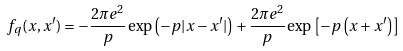Convert formula to latex. <formula><loc_0><loc_0><loc_500><loc_500>f _ { q } ( x , x ^ { \prime } ) = - \frac { 2 \pi e ^ { 2 } } { p } \exp \left ( - p | x - x ^ { \prime } | \right ) + \frac { 2 \pi e ^ { 2 } } { p } \exp \left [ - p \left ( x + x ^ { \prime } \right ) \right ]</formula> 